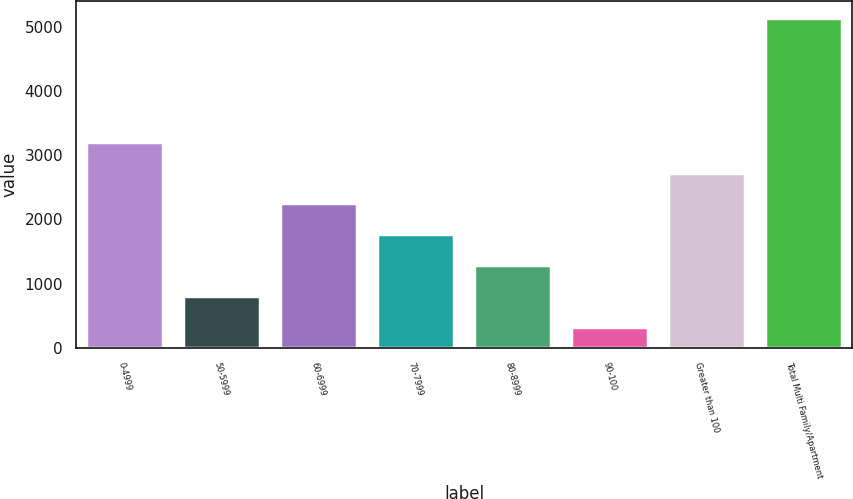Convert chart to OTSL. <chart><loc_0><loc_0><loc_500><loc_500><bar_chart><fcel>0-4999<fcel>50-5999<fcel>60-6999<fcel>70-7999<fcel>80-8999<fcel>90-100<fcel>Greater than 100<fcel>Total Multi Family/Apartment<nl><fcel>3213.2<fcel>804.7<fcel>2249.8<fcel>1768.1<fcel>1286.4<fcel>323<fcel>2731.5<fcel>5140<nl></chart> 